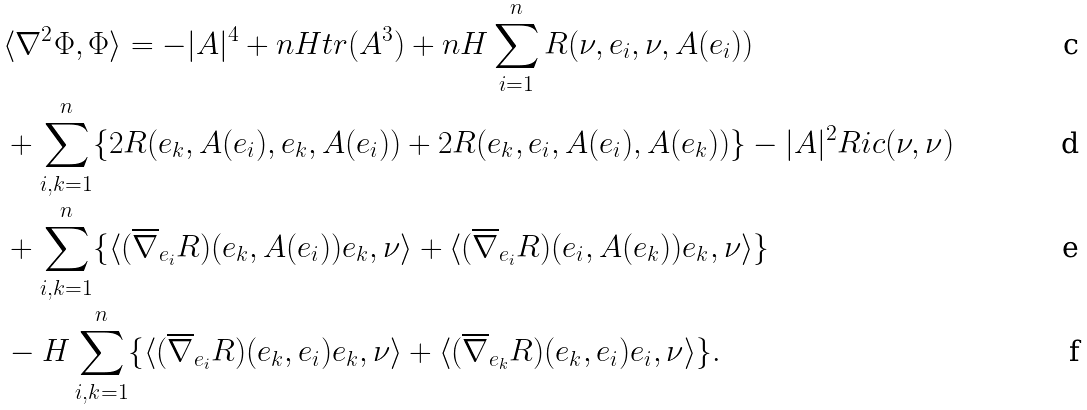Convert formula to latex. <formula><loc_0><loc_0><loc_500><loc_500>& \langle \nabla ^ { 2 } \Phi , \Phi \rangle = - | A | ^ { 4 } + n H t r ( A ^ { 3 } ) + n H \sum _ { i = 1 } ^ { n } R ( \nu , e _ { i } , \nu , A ( e _ { i } ) ) \\ & + \sum _ { i , k = 1 } ^ { n } \{ 2 R ( e _ { k } , A ( e _ { i } ) , e _ { k } , A ( e _ { i } ) ) + 2 R ( e _ { k } , e _ { i } , A ( e _ { i } ) , A ( e _ { k } ) ) \} - | A | ^ { 2 } R i c ( \nu , \nu ) \\ & + \sum _ { i , k = 1 } ^ { n } \{ \langle ( \overline { \nabla } _ { e _ { i } } R ) ( e _ { k } , A ( e _ { i } ) ) e _ { k } , \nu \rangle + \langle ( \overline { \nabla } _ { e _ { i } } R ) ( e _ { i } , A ( e _ { k } ) ) e _ { k } , \nu \rangle \} \\ & - H \sum _ { i , k = 1 } ^ { n } \{ \langle ( \overline { \nabla } _ { e _ { i } } R ) ( e _ { k } , e _ { i } ) e _ { k } , \nu \rangle + \langle ( \overline { \nabla } _ { e _ { k } } R ) ( e _ { k } , e _ { i } ) e _ { i } , \nu \rangle \} .</formula> 